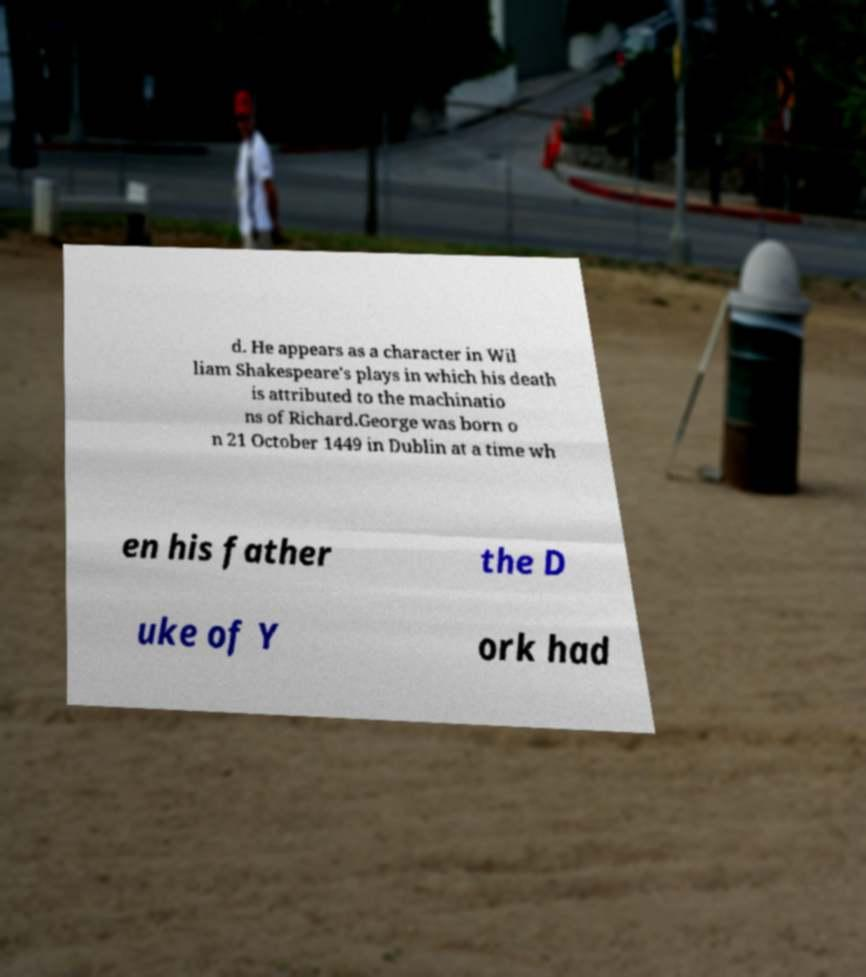For documentation purposes, I need the text within this image transcribed. Could you provide that? d. He appears as a character in Wil liam Shakespeare's plays in which his death is attributed to the machinatio ns of Richard.George was born o n 21 October 1449 in Dublin at a time wh en his father the D uke of Y ork had 